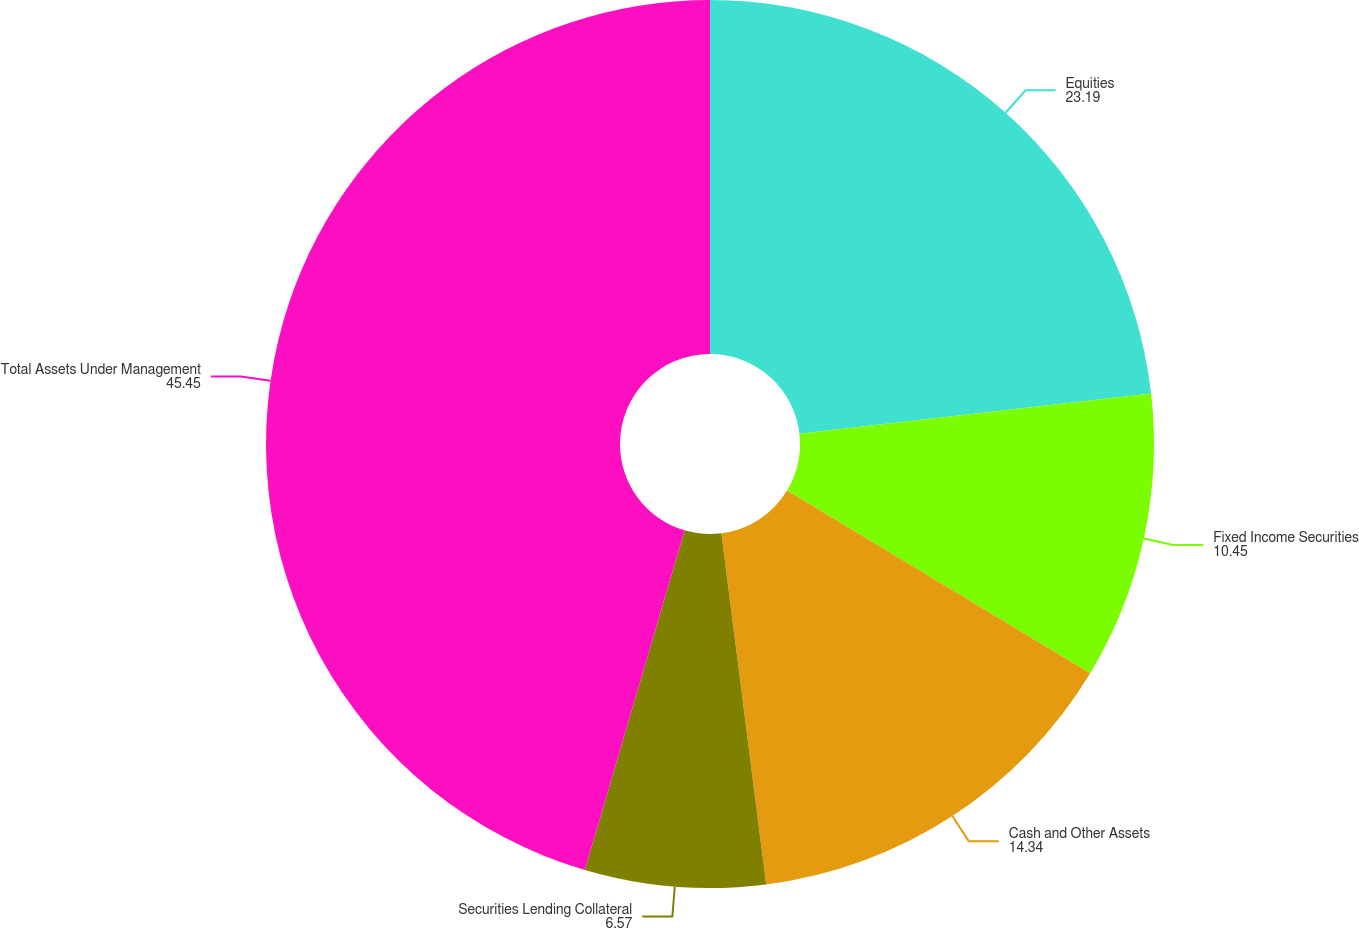Convert chart to OTSL. <chart><loc_0><loc_0><loc_500><loc_500><pie_chart><fcel>Equities<fcel>Fixed Income Securities<fcel>Cash and Other Assets<fcel>Securities Lending Collateral<fcel>Total Assets Under Management<nl><fcel>23.19%<fcel>10.45%<fcel>14.34%<fcel>6.57%<fcel>45.45%<nl></chart> 